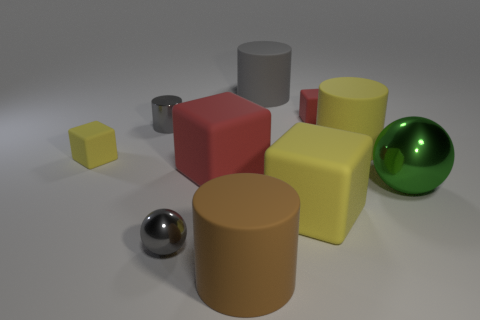Subtract all large yellow matte cubes. How many cubes are left? 3 Subtract 0 gray blocks. How many objects are left? 10 Subtract all cylinders. How many objects are left? 6 Subtract 1 balls. How many balls are left? 1 Subtract all cyan cylinders. Subtract all purple blocks. How many cylinders are left? 4 Subtract all purple cubes. How many gray balls are left? 1 Subtract all tiny red rubber blocks. Subtract all tiny metal cylinders. How many objects are left? 8 Add 5 small rubber blocks. How many small rubber blocks are left? 7 Add 2 tiny yellow rubber objects. How many tiny yellow rubber objects exist? 3 Subtract all yellow cubes. How many cubes are left? 2 